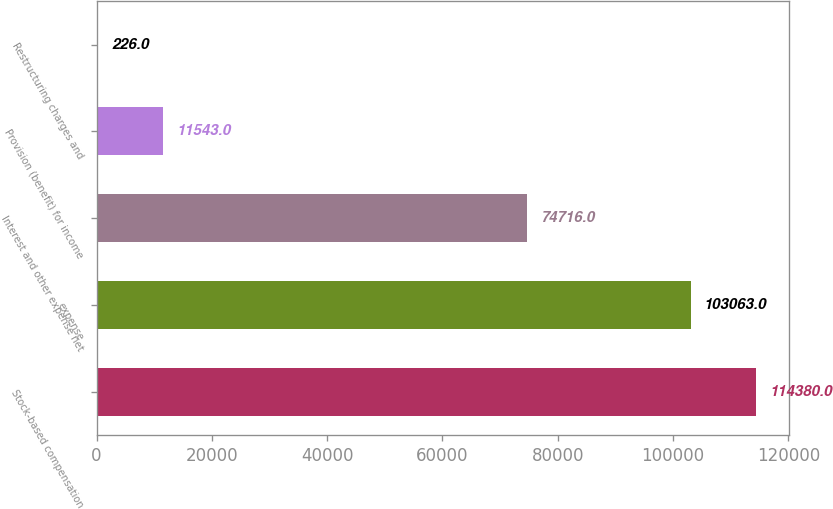<chart> <loc_0><loc_0><loc_500><loc_500><bar_chart><fcel>Stock-based compensation<fcel>expense<fcel>Interest and other expense net<fcel>Provision (benefit) for income<fcel>Restructuring charges and<nl><fcel>114380<fcel>103063<fcel>74716<fcel>11543<fcel>226<nl></chart> 